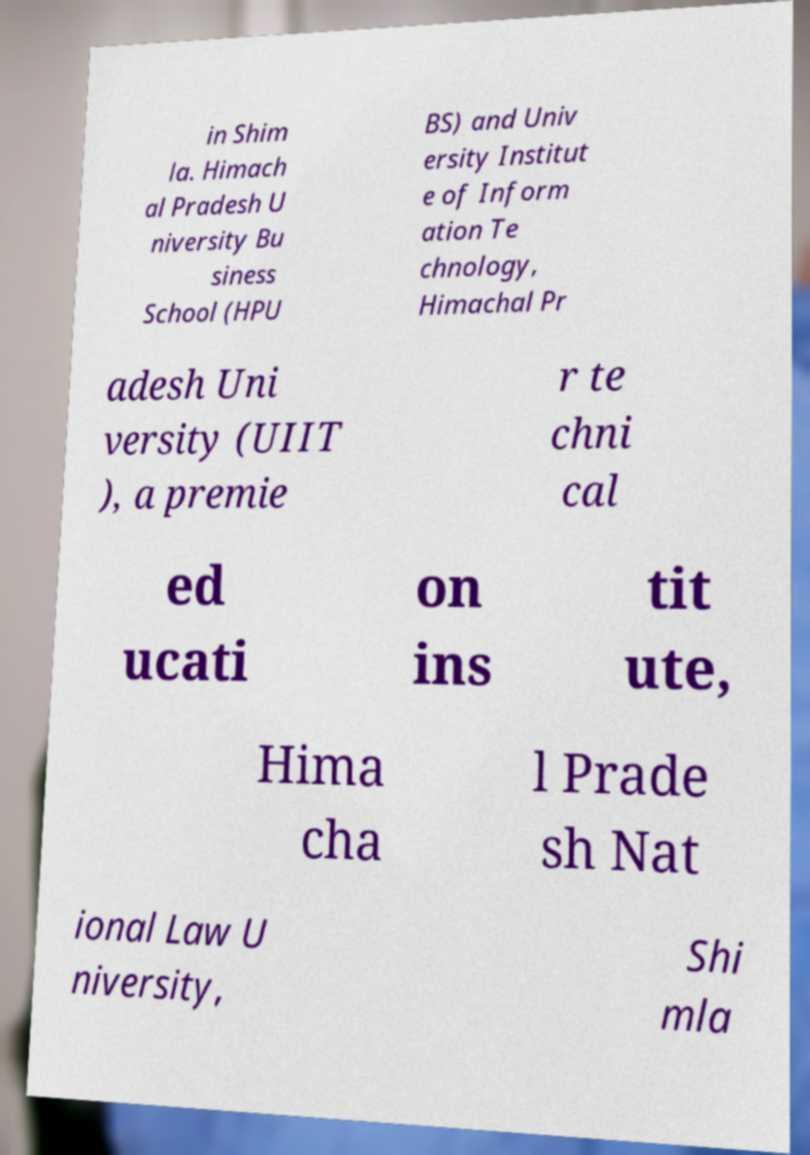For documentation purposes, I need the text within this image transcribed. Could you provide that? in Shim la. Himach al Pradesh U niversity Bu siness School (HPU BS) and Univ ersity Institut e of Inform ation Te chnology, Himachal Pr adesh Uni versity (UIIT ), a premie r te chni cal ed ucati on ins tit ute, Hima cha l Prade sh Nat ional Law U niversity, Shi mla 